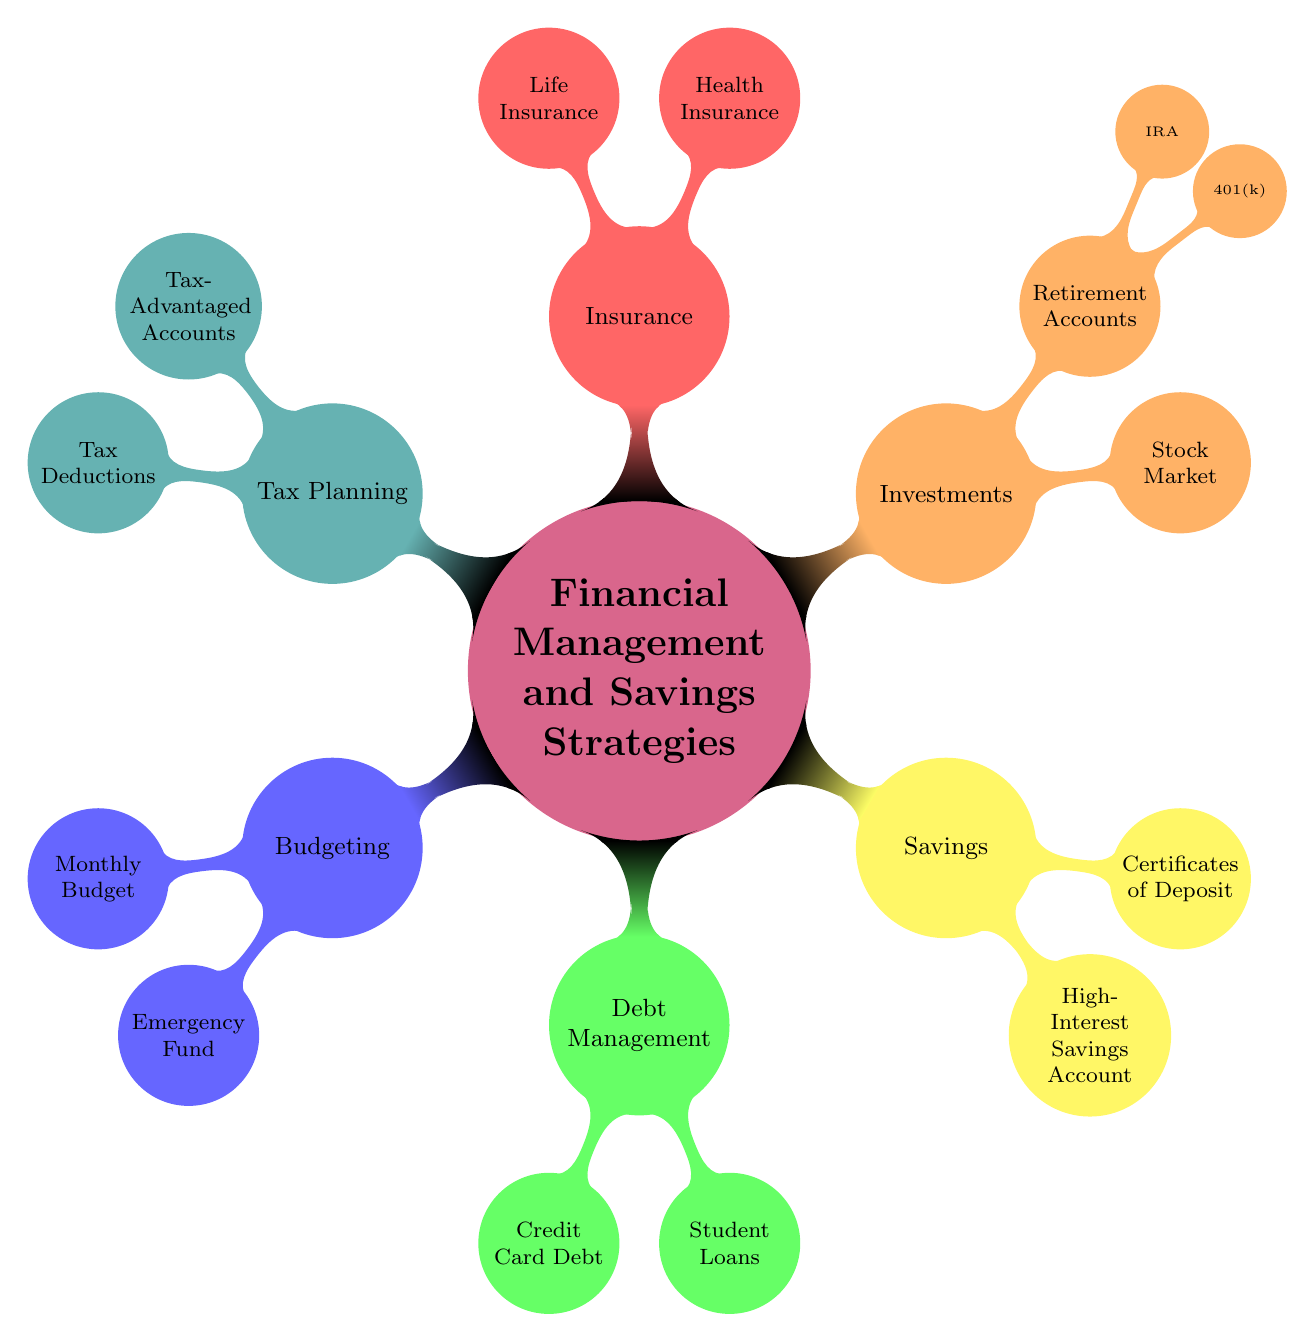What are the two main categories under "Savings"? The "Savings" section in the diagram has two main categories listed beneath it: "High-Interest Savings Account" and "Certificates of Deposit".
Answer: High-Interest Savings Account, Certificates of Deposit How many subcategories does "Investments" have? Under the "Investments" section, there are three subcategories: "Stock Market", "Retirement Accounts" (which further splits into "401(k)" and "IRA"). Therefore, there are a total of three subcategories under "Investments".
Answer: 3 What is included in "Debt Management"? The "Debt Management" section contains two specific items: "Credit Card Debt" and "Student Loans".
Answer: Credit Card Debt, Student Loans What type of accounts fall under "Tax Planning"? The "Tax Planning" section specifically mentions "Tax-Advantaged Accounts" and "Tax Deductions" as the types of accounts included under it.
Answer: Tax-Advantaged Accounts, Tax Deductions Which category has a child node that deals with insurance? The category "Insurance" directly addresses the topic of insurance within the mind map, specifically mentioning "Health Insurance" and "Life Insurance".
Answer: Insurance How is "Emergency Fund" related to "Budgeting"? "Emergency Fund" is a child node under the "Budgeting" section, indicating that it is a strategy or component of effective budgeting practices.
Answer: Child node Which category addresses retirement savings? The "Investments" category has a subcategory called "Retirement Accounts", which addresses retirement savings.
Answer: Investments What is the focus of the "Certificates of Deposit"? The "Certificates of Deposit" node under "Savings" refers to investing in CDs for better returns, indicating a focus on saving with higher interest accumulation.
Answer: Investing in CDs for better returns What is the strategy for "Credit Card Debt"? The strategy noted for "Credit Card Debt" in the "Debt Management" section is to focus on paying down high-interest credit card balances.
Answer: Paying down high-interest credit card balances 